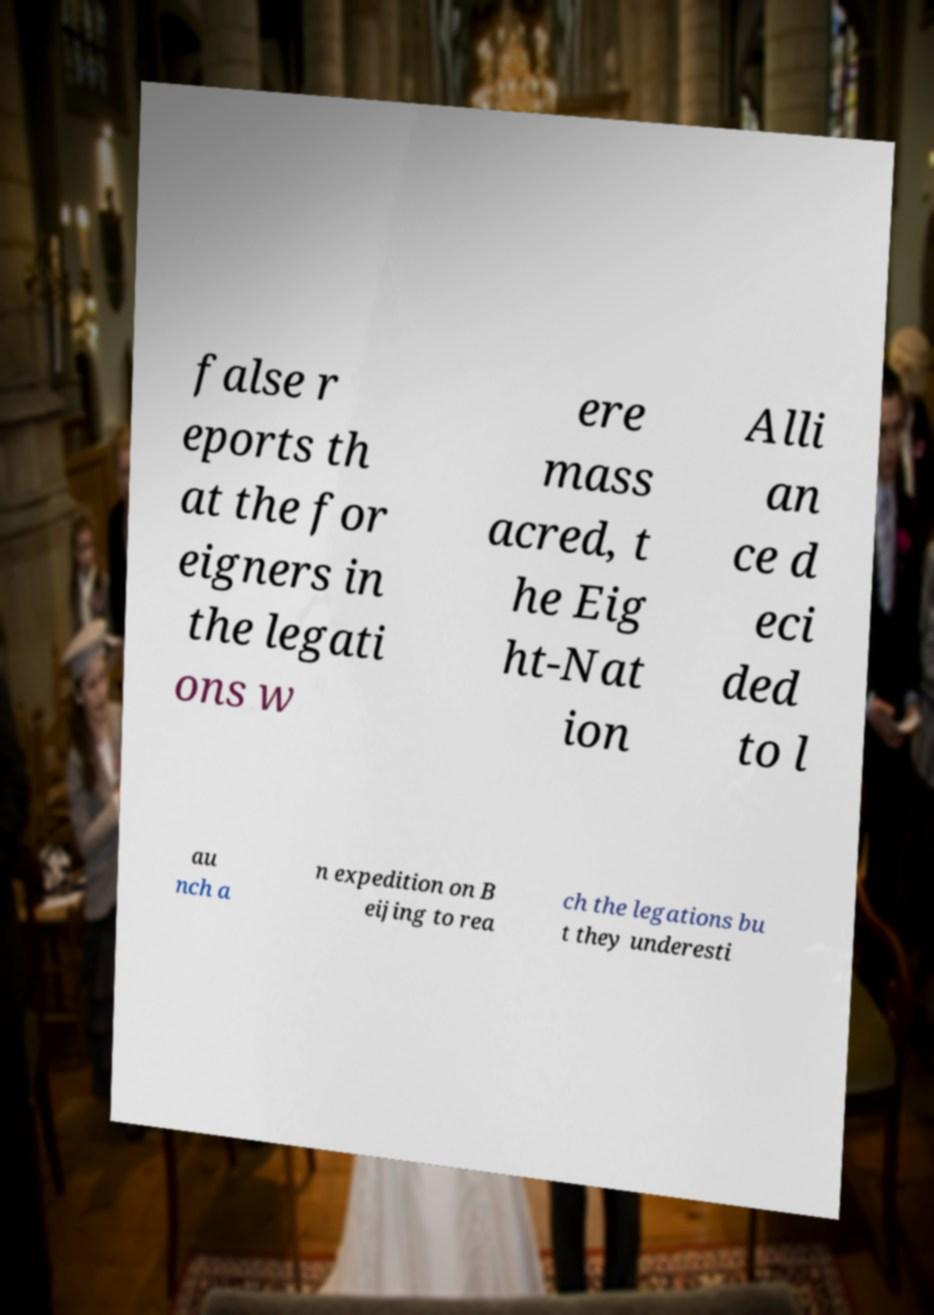Can you read and provide the text displayed in the image?This photo seems to have some interesting text. Can you extract and type it out for me? false r eports th at the for eigners in the legati ons w ere mass acred, t he Eig ht-Nat ion Alli an ce d eci ded to l au nch a n expedition on B eijing to rea ch the legations bu t they underesti 